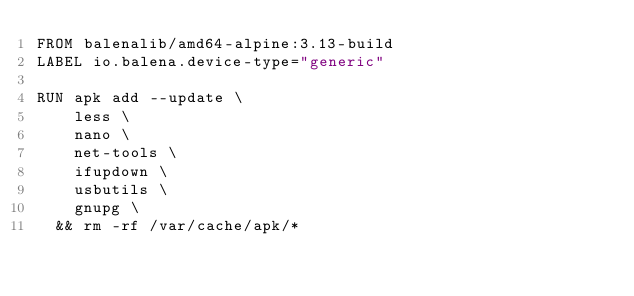<code> <loc_0><loc_0><loc_500><loc_500><_Dockerfile_>FROM balenalib/amd64-alpine:3.13-build
LABEL io.balena.device-type="generic"

RUN apk add --update \
		less \
		nano \
		net-tools \
		ifupdown \
		usbutils \
		gnupg \
	&& rm -rf /var/cache/apk/*
</code> 